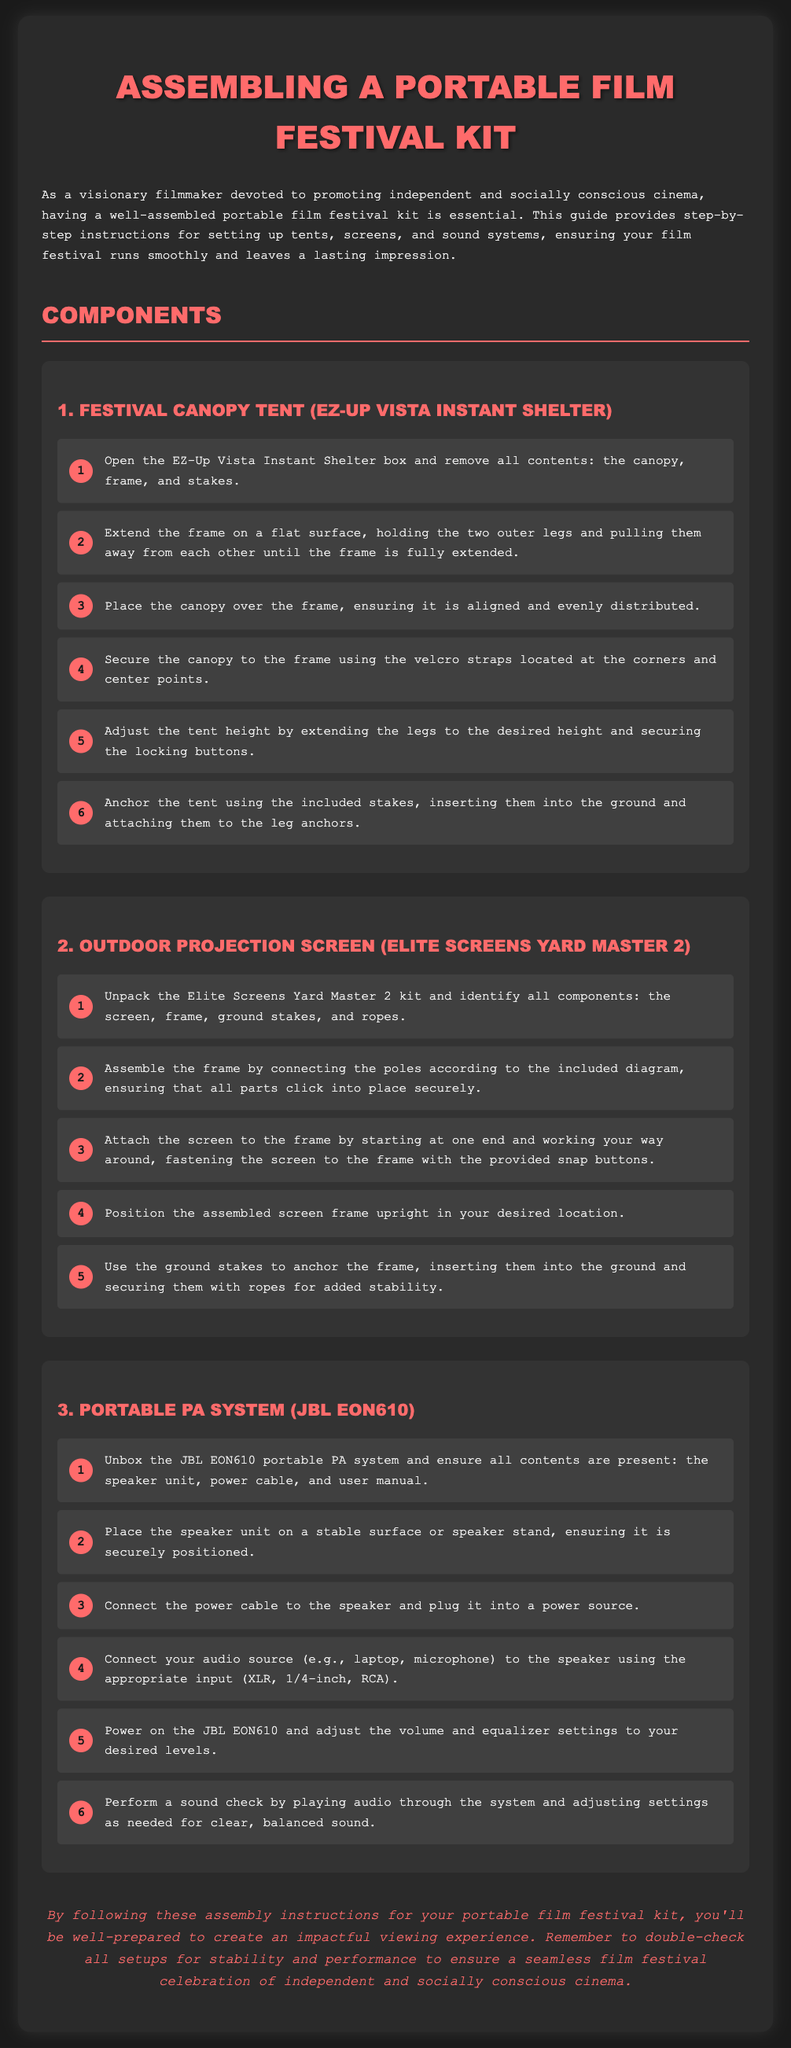what is the title of the document? The title is explicitly stated in the document as "Assembling a Portable Film Festival Kit".
Answer: Assembling a Portable Film Festival Kit how many steps are there to assemble the Festival Canopy Tent? The instructions list 6 steps to assemble the Festival Canopy Tent.
Answer: 6 what is the brand of the Portable PA System? The Portable PA System is identified as a product from the brand JBL.
Answer: JBL what is the first step for setting up the Outdoor Projection Screen? The first step involves unpacking the Elite Screens Yard Master 2 kit and identifying all components.
Answer: Unpack the Elite Screens Yard Master 2 kit how should the tent be anchored? The tent should be anchored using the included stakes, inserted into the ground and attached to the leg anchors.
Answer: Using stakes how many components are listed for the Portable Film Festival Kit? There are 3 components listed for the kit: the Festival Canopy Tent, Outdoor Projection Screen, and Portable PA System.
Answer: 3 what is the purpose of this assembly guide? The purpose of the guide is to provide step-by-step instructions to ensure a smooth and impactful film festival experience.
Answer: To provide step-by-step instructions where should the speaker unit be placed? The speaker unit should be placed on a stable surface or speaker stand.
Answer: Stable surface 